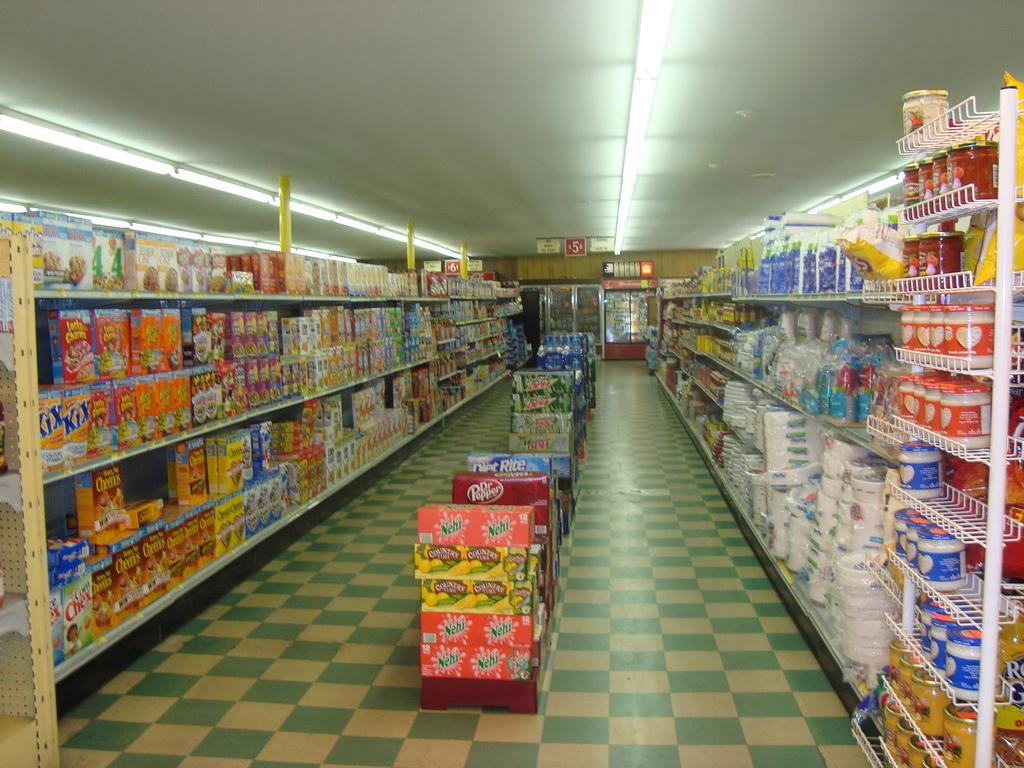<image>
Share a concise interpretation of the image provided. Store Isle that shows Cereal and other types of items like Sugar and Soda, I see Lucky Charms, Kix, and Reeses Puffs. 